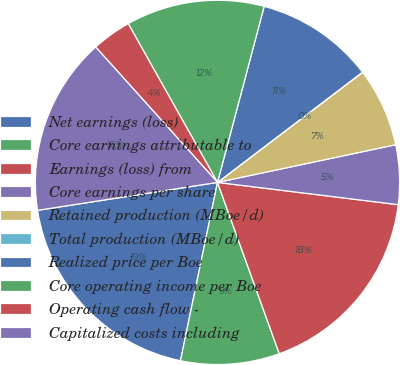Convert chart. <chart><loc_0><loc_0><loc_500><loc_500><pie_chart><fcel>Net earnings (loss)<fcel>Core earnings attributable to<fcel>Earnings (loss) from<fcel>Core earnings per share<fcel>Retained production (MBoe/d)<fcel>Total production (MBoe/d)<fcel>Realized price per Boe<fcel>Core operating income per Boe<fcel>Operating cash flow -<fcel>Capitalized costs including<nl><fcel>19.29%<fcel>8.77%<fcel>17.54%<fcel>5.27%<fcel>7.02%<fcel>0.01%<fcel>10.53%<fcel>12.28%<fcel>3.51%<fcel>15.79%<nl></chart> 